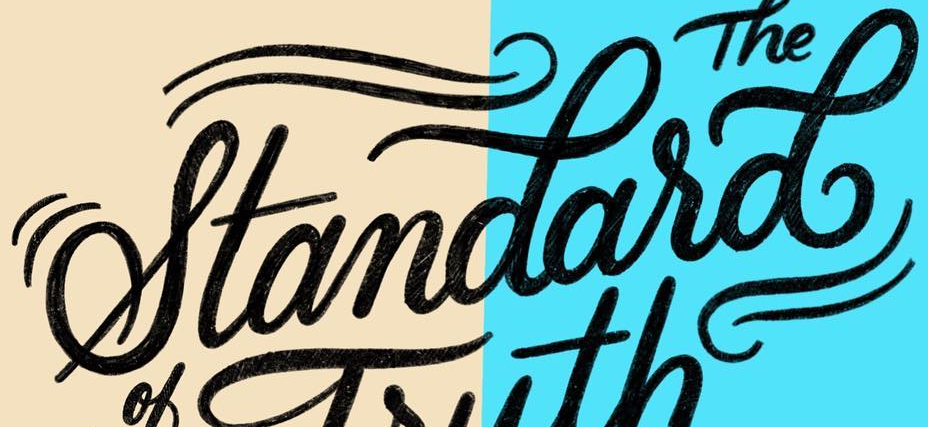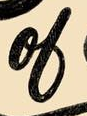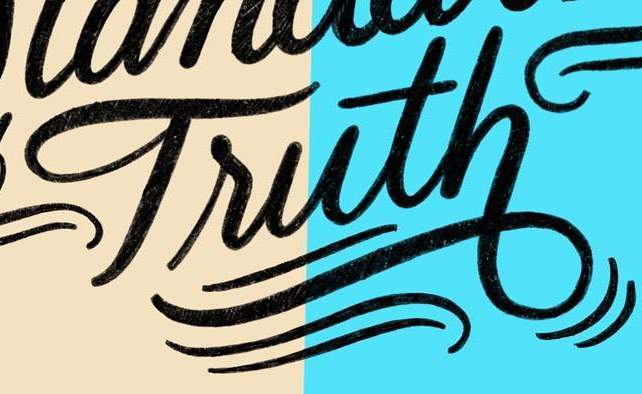What words are shown in these images in order, separated by a semicolon? standasd; ol; Truth 